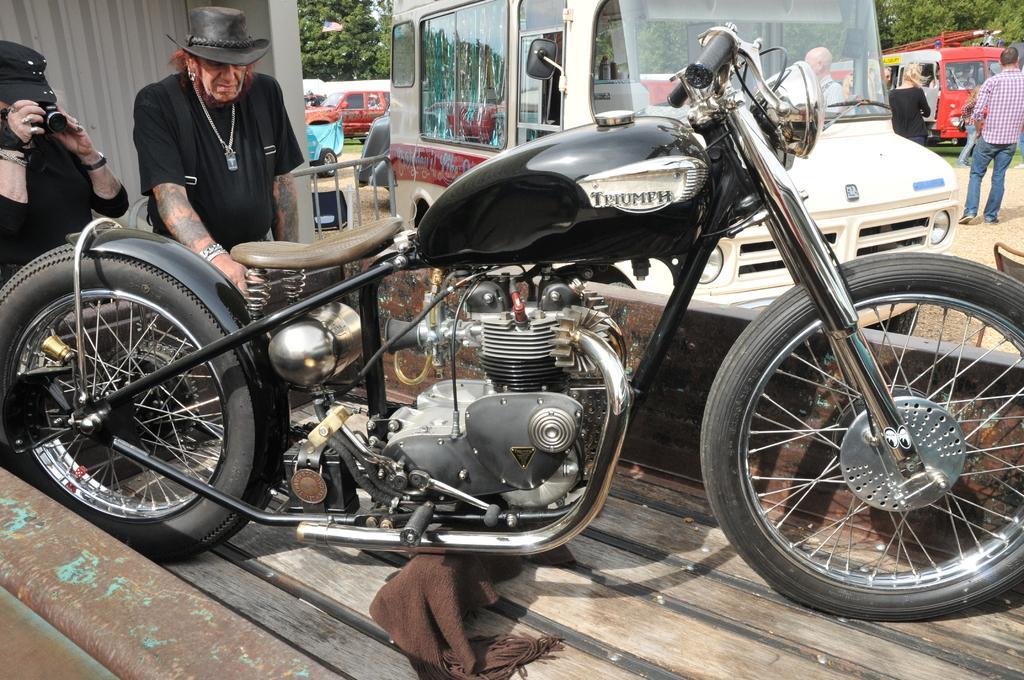Can you describe this image briefly? In this image I can see the motorbike and two people wearing the black color dresses and one person holding the camera. In the background I can see many vehicles on the ground. To the side of few vehicles I can see the group of people with different color dresses. In the background I can see many trees. 